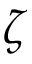<formula> <loc_0><loc_0><loc_500><loc_500>\zeta</formula> 